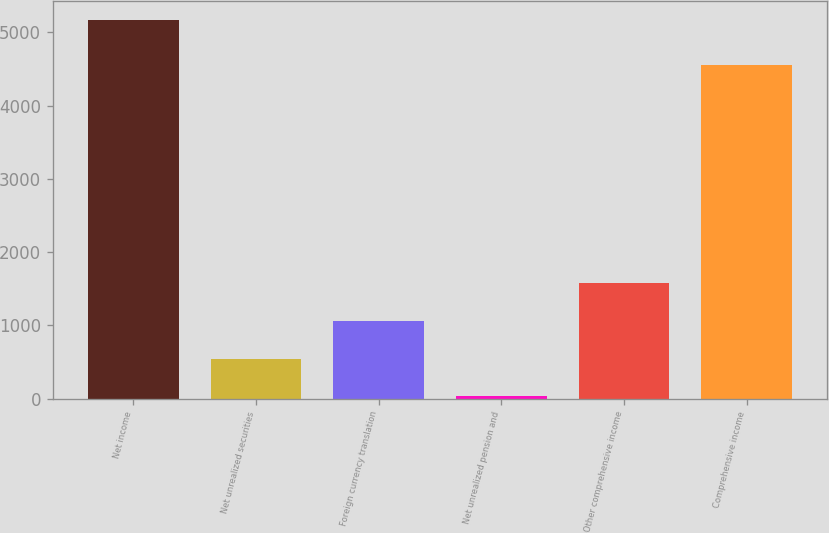<chart> <loc_0><loc_0><loc_500><loc_500><bar_chart><fcel>Net income<fcel>Net unrealized securities<fcel>Foreign currency translation<fcel>Net unrealized pension and<fcel>Other comprehensive income<fcel>Comprehensive income<nl><fcel>5163<fcel>545.1<fcel>1058.2<fcel>32<fcel>1571.3<fcel>4548<nl></chart> 